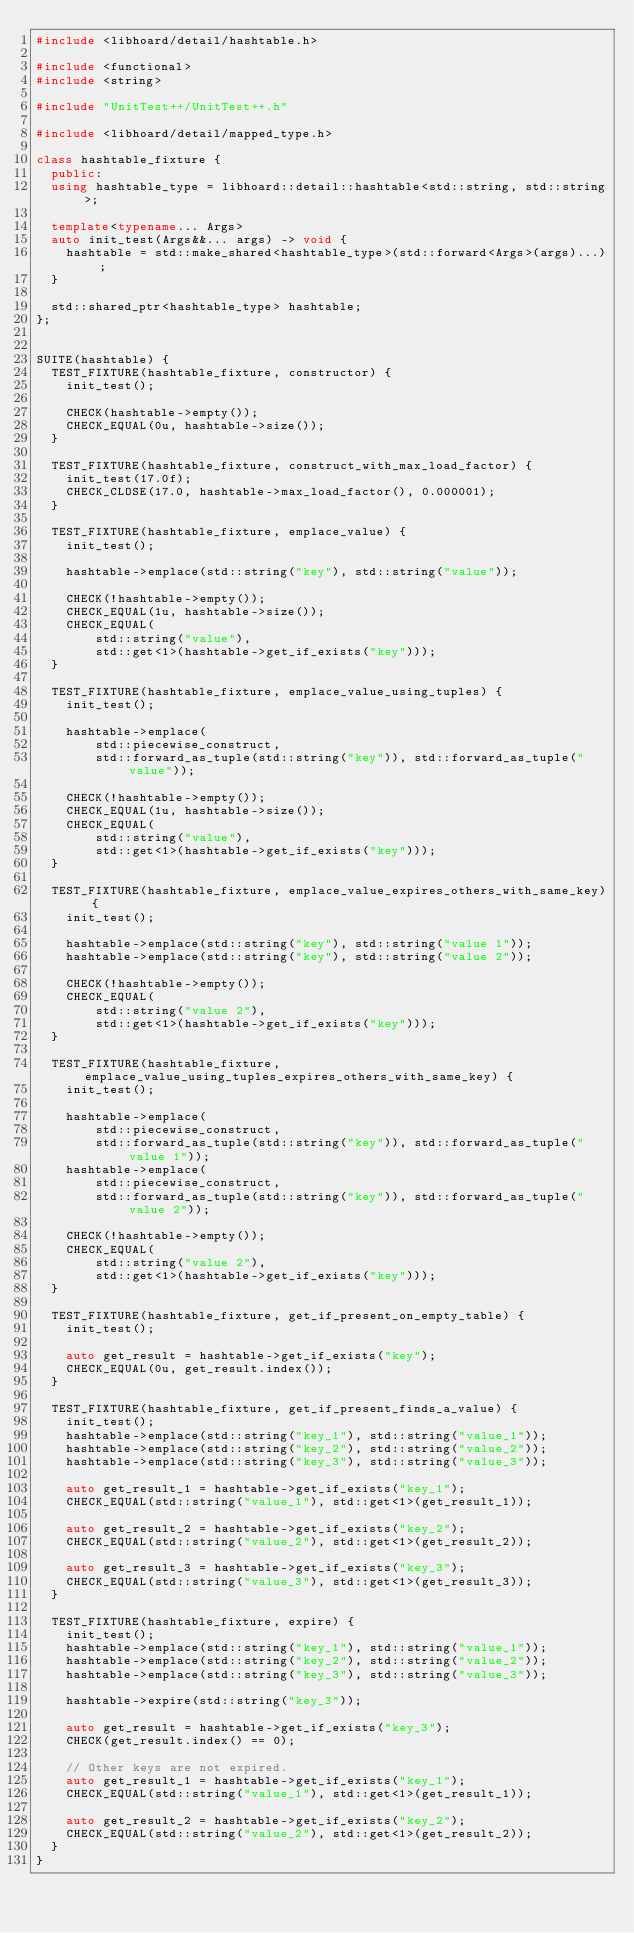<code> <loc_0><loc_0><loc_500><loc_500><_C++_>#include <libhoard/detail/hashtable.h>

#include <functional>
#include <string>

#include "UnitTest++/UnitTest++.h"

#include <libhoard/detail/mapped_type.h>

class hashtable_fixture {
  public:
  using hashtable_type = libhoard::detail::hashtable<std::string, std::string>;

  template<typename... Args>
  auto init_test(Args&&... args) -> void {
    hashtable = std::make_shared<hashtable_type>(std::forward<Args>(args)...);
  }

  std::shared_ptr<hashtable_type> hashtable;
};


SUITE(hashtable) {
  TEST_FIXTURE(hashtable_fixture, constructor) {
    init_test();

    CHECK(hashtable->empty());
    CHECK_EQUAL(0u, hashtable->size());
  }

  TEST_FIXTURE(hashtable_fixture, construct_with_max_load_factor) {
    init_test(17.0f);
    CHECK_CLOSE(17.0, hashtable->max_load_factor(), 0.000001);
  }

  TEST_FIXTURE(hashtable_fixture, emplace_value) {
    init_test();

    hashtable->emplace(std::string("key"), std::string("value"));

    CHECK(!hashtable->empty());
    CHECK_EQUAL(1u, hashtable->size());
    CHECK_EQUAL(
        std::string("value"),
        std::get<1>(hashtable->get_if_exists("key")));
  }

  TEST_FIXTURE(hashtable_fixture, emplace_value_using_tuples) {
    init_test();

    hashtable->emplace(
        std::piecewise_construct,
        std::forward_as_tuple(std::string("key")), std::forward_as_tuple("value"));

    CHECK(!hashtable->empty());
    CHECK_EQUAL(1u, hashtable->size());
    CHECK_EQUAL(
        std::string("value"),
        std::get<1>(hashtable->get_if_exists("key")));
  }

  TEST_FIXTURE(hashtable_fixture, emplace_value_expires_others_with_same_key) {
    init_test();

    hashtable->emplace(std::string("key"), std::string("value 1"));
    hashtable->emplace(std::string("key"), std::string("value 2"));

    CHECK(!hashtable->empty());
    CHECK_EQUAL(
        std::string("value 2"),
        std::get<1>(hashtable->get_if_exists("key")));
  }

  TEST_FIXTURE(hashtable_fixture, emplace_value_using_tuples_expires_others_with_same_key) {
    init_test();

    hashtable->emplace(
        std::piecewise_construct,
        std::forward_as_tuple(std::string("key")), std::forward_as_tuple("value 1"));
    hashtable->emplace(
        std::piecewise_construct,
        std::forward_as_tuple(std::string("key")), std::forward_as_tuple("value 2"));

    CHECK(!hashtable->empty());
    CHECK_EQUAL(
        std::string("value 2"),
        std::get<1>(hashtable->get_if_exists("key")));
  }

  TEST_FIXTURE(hashtable_fixture, get_if_present_on_empty_table) {
    init_test();

    auto get_result = hashtable->get_if_exists("key");
    CHECK_EQUAL(0u, get_result.index());
  }

  TEST_FIXTURE(hashtable_fixture, get_if_present_finds_a_value) {
    init_test();
    hashtable->emplace(std::string("key_1"), std::string("value_1"));
    hashtable->emplace(std::string("key_2"), std::string("value_2"));
    hashtable->emplace(std::string("key_3"), std::string("value_3"));

    auto get_result_1 = hashtable->get_if_exists("key_1");
    CHECK_EQUAL(std::string("value_1"), std::get<1>(get_result_1));

    auto get_result_2 = hashtable->get_if_exists("key_2");
    CHECK_EQUAL(std::string("value_2"), std::get<1>(get_result_2));

    auto get_result_3 = hashtable->get_if_exists("key_3");
    CHECK_EQUAL(std::string("value_3"), std::get<1>(get_result_3));
  }

  TEST_FIXTURE(hashtable_fixture, expire) {
    init_test();
    hashtable->emplace(std::string("key_1"), std::string("value_1"));
    hashtable->emplace(std::string("key_2"), std::string("value_2"));
    hashtable->emplace(std::string("key_3"), std::string("value_3"));

    hashtable->expire(std::string("key_3"));

    auto get_result = hashtable->get_if_exists("key_3");
    CHECK(get_result.index() == 0);

    // Other keys are not expired.
    auto get_result_1 = hashtable->get_if_exists("key_1");
    CHECK_EQUAL(std::string("value_1"), std::get<1>(get_result_1));

    auto get_result_2 = hashtable->get_if_exists("key_2");
    CHECK_EQUAL(std::string("value_2"), std::get<1>(get_result_2));
  }
}
</code> 